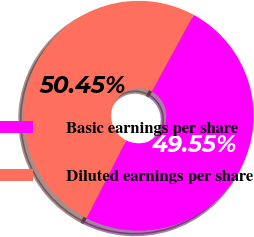Convert chart. <chart><loc_0><loc_0><loc_500><loc_500><pie_chart><fcel>Basic earnings per share<fcel>Diluted earnings per share<nl><fcel>49.55%<fcel>50.45%<nl></chart> 